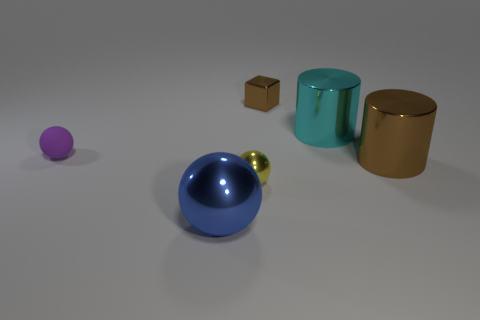Add 1 large brown metal cylinders. How many objects exist? 7 Subtract all blue balls. How many balls are left? 2 Subtract all purple balls. How many balls are left? 2 Subtract 0 purple cylinders. How many objects are left? 6 Subtract all cubes. How many objects are left? 5 Subtract 1 blocks. How many blocks are left? 0 Subtract all yellow cylinders. Subtract all yellow blocks. How many cylinders are left? 2 Subtract all blue blocks. How many cyan cylinders are left? 1 Subtract all tiny rubber cylinders. Subtract all shiny things. How many objects are left? 1 Add 4 brown shiny objects. How many brown shiny objects are left? 6 